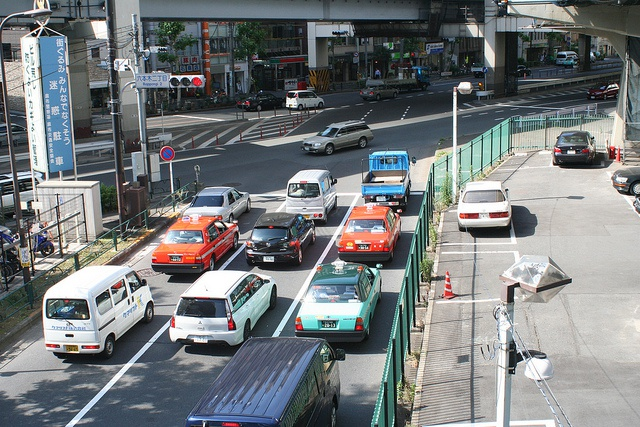Describe the objects in this image and their specific colors. I can see truck in gray and black tones, car in gray, white, black, and darkgray tones, car in gray, white, black, darkgray, and lightblue tones, car in gray, black, lightgray, and darkgray tones, and car in gray, white, black, and teal tones in this image. 